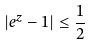<formula> <loc_0><loc_0><loc_500><loc_500>| e ^ { z } - 1 | \leq \frac { 1 } { 2 }</formula> 